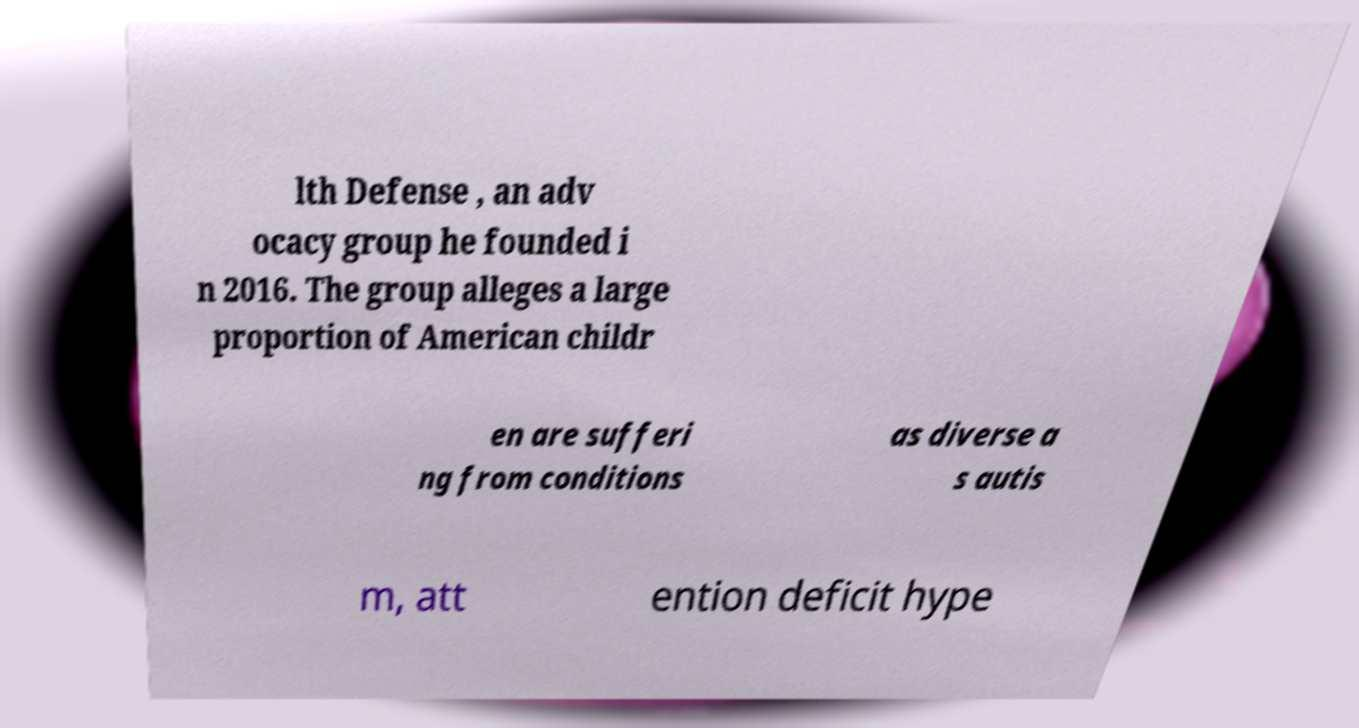What messages or text are displayed in this image? I need them in a readable, typed format. lth Defense , an adv ocacy group he founded i n 2016. The group alleges a large proportion of American childr en are sufferi ng from conditions as diverse a s autis m, att ention deficit hype 